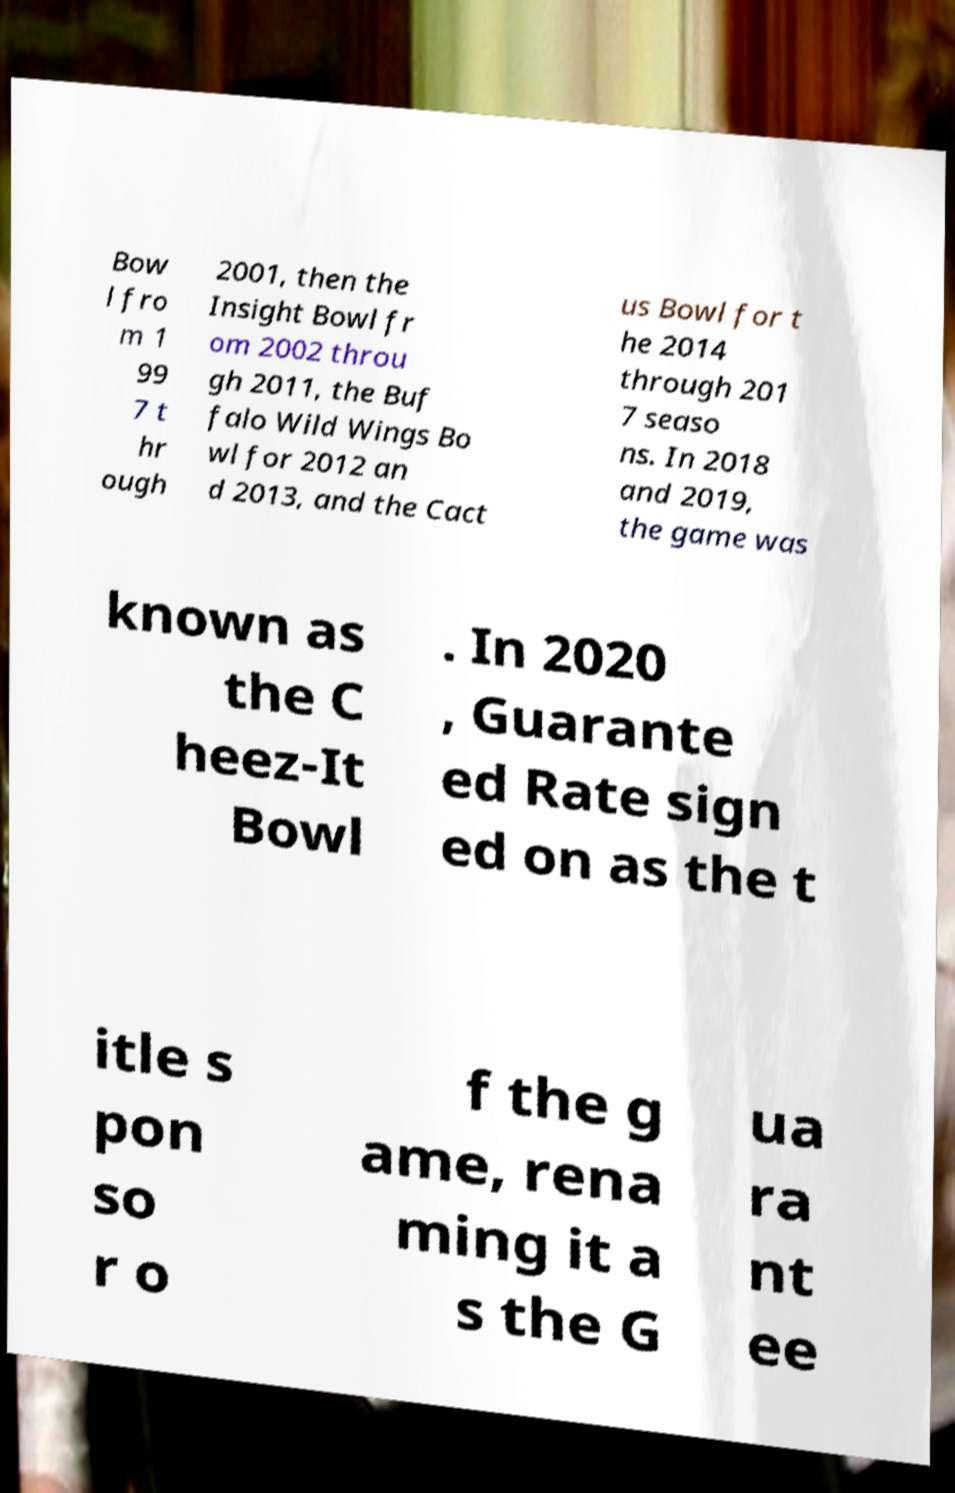For documentation purposes, I need the text within this image transcribed. Could you provide that? Bow l fro m 1 99 7 t hr ough 2001, then the Insight Bowl fr om 2002 throu gh 2011, the Buf falo Wild Wings Bo wl for 2012 an d 2013, and the Cact us Bowl for t he 2014 through 201 7 seaso ns. In 2018 and 2019, the game was known as the C heez-It Bowl . In 2020 , Guarante ed Rate sign ed on as the t itle s pon so r o f the g ame, rena ming it a s the G ua ra nt ee 